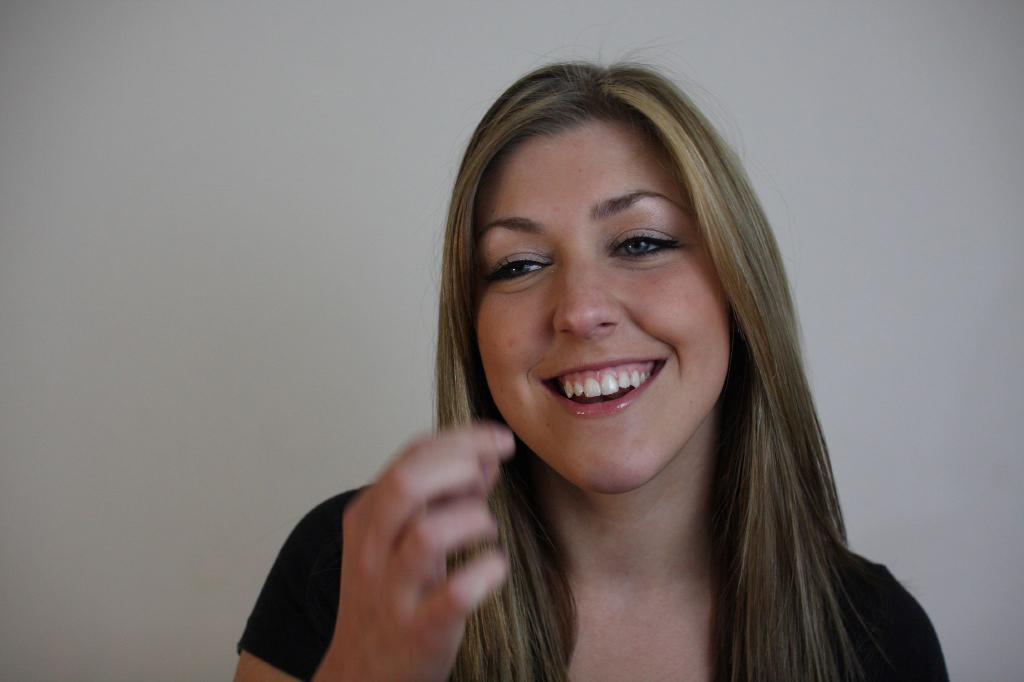Who is present in the image? There is a woman in the image. What expression does the woman have? The woman is smiling. What amount of regret can be seen on the woman's face in the image? There is no indication of regret on the woman's face in the image; she is smiling. 